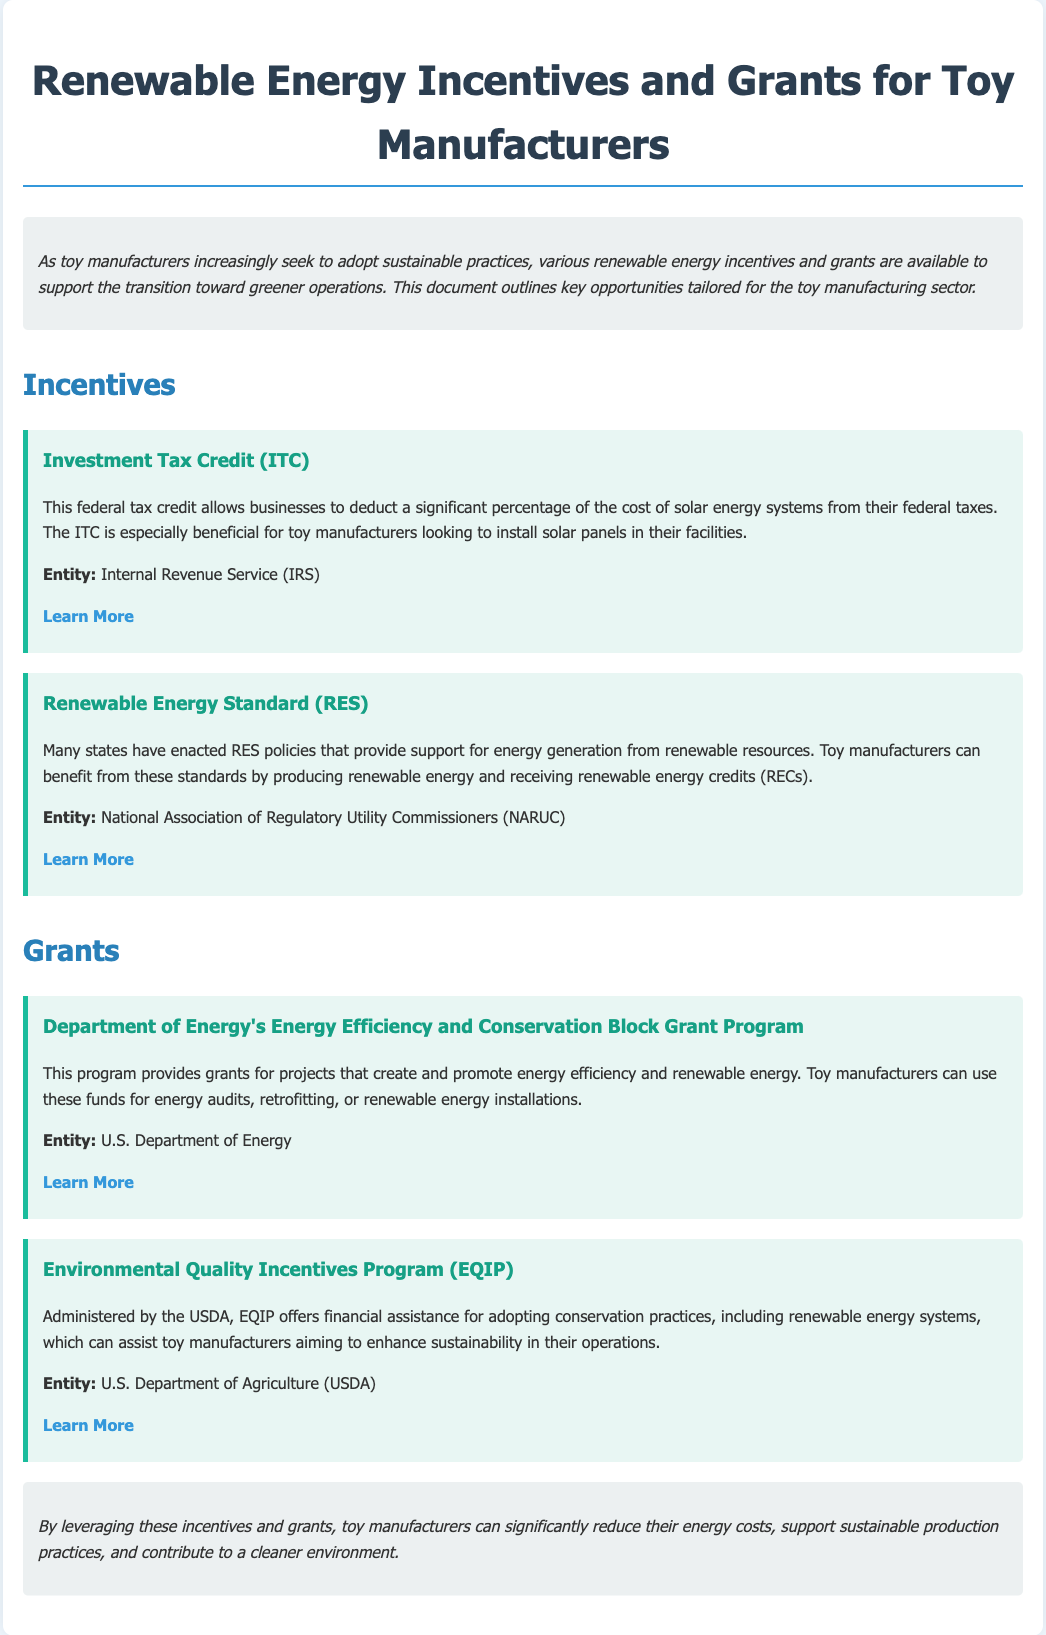What is the title of the document? The title is clearly stated at the top of the document, providing the main focus.
Answer: Renewable Energy Incentives and Grants for Toy Manufacturers What is the federal tax credit mentioned for toy manufacturers? The document specifies the type of tax credit available for installing solar energy systems.
Answer: Investment Tax Credit (ITC) Which department administers the Environmental Quality Incentives Program? The document identifies the overseeing department responsible for this program.
Answer: U.S. Department of Agriculture (USDA) What kind of standard is mentioned as a support for renewable energy generation? The document highlights a specific policy that assists manufacturers in generating renewable energy.
Answer: Renewable Energy Standard (RES) What does the Department of Energy's program provide grants for? The document details the purpose of the grants offered through this program.
Answer: Energy efficiency and renewable energy Which entity is responsible for the Investment Tax Credit? The document lists the organization that manages this tax credit.
Answer: Internal Revenue Service (IRS) How many grants are listed in the document? The structure of the document allows for a quick count of the individual grant sections.
Answer: Two What is the aim of the Energy Efficiency and Conservation Block Grant Program? The document articulates the goal of this specific grant program for manufacturers.
Answer: Promote energy efficiency and renewable energy What color theme is used for the item sections? The visual style indicated the specific color choice for these sections of the document.
Answer: Light blue 